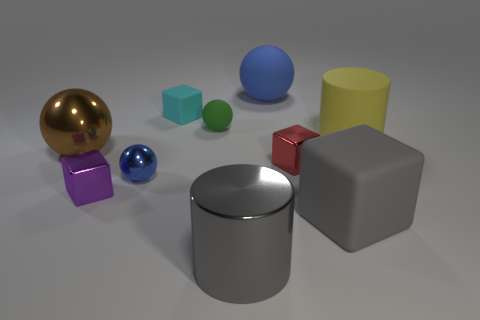Subtract all spheres. How many objects are left? 6 Add 6 tiny blue shiny things. How many tiny blue shiny things exist? 7 Subtract 0 brown cylinders. How many objects are left? 10 Subtract all yellow cylinders. Subtract all matte cylinders. How many objects are left? 8 Add 5 gray metal objects. How many gray metal objects are left? 6 